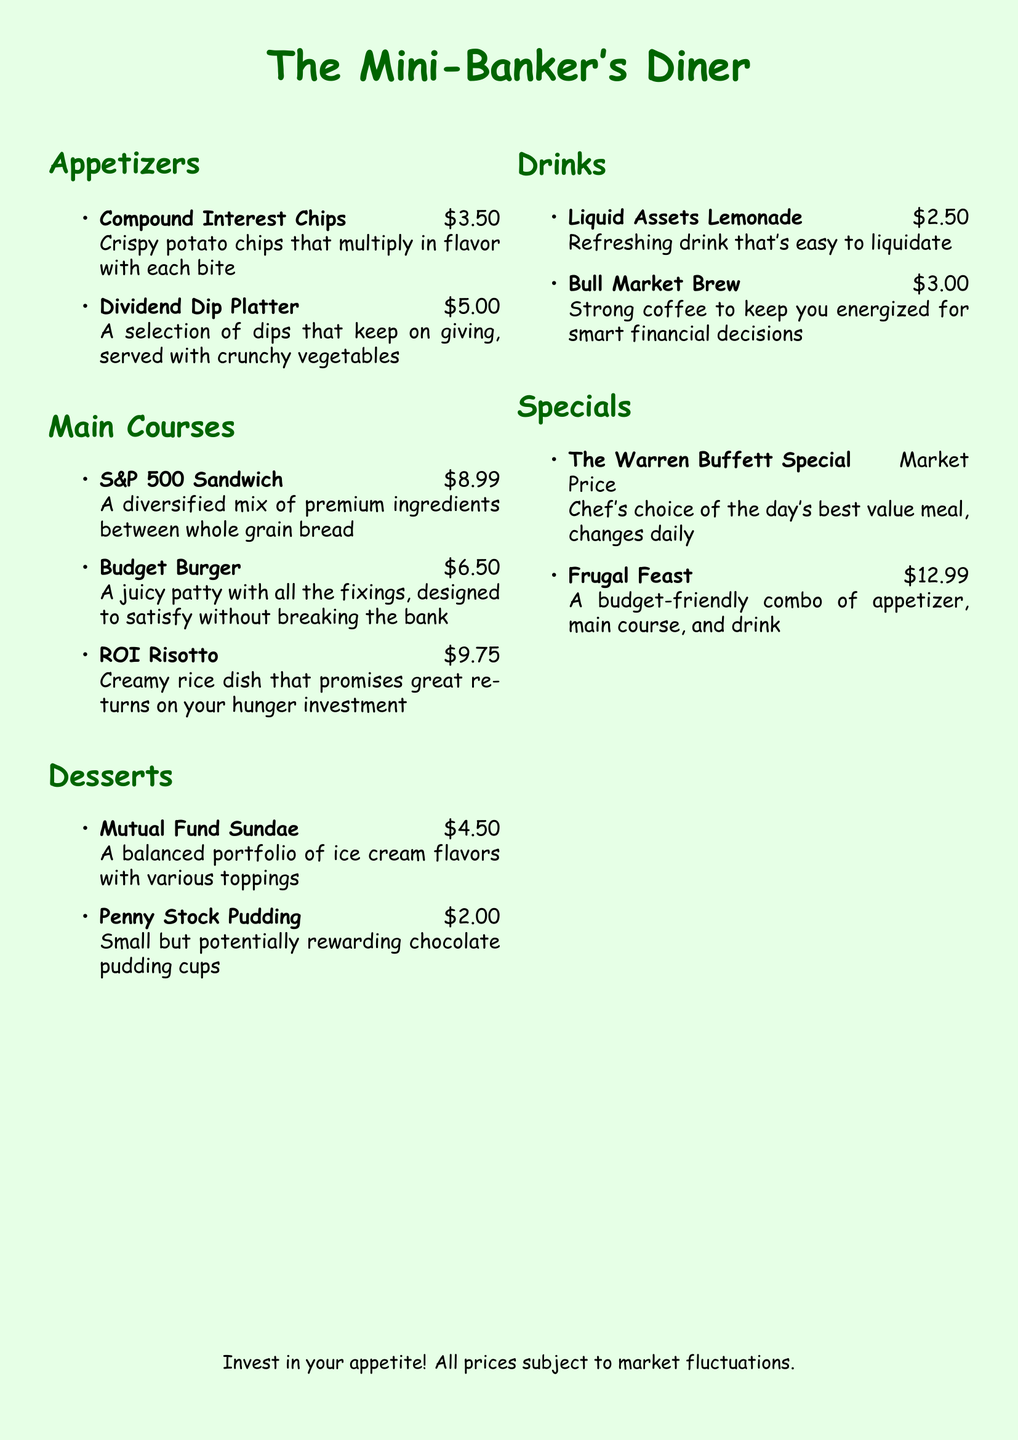what is the price of the Compound Interest Chips? The price of the Compound Interest Chips is stated in the appetizers section of the menu.
Answer: $3.50 which drink is referred to as "Liquid Assets"? The drink called "Liquid Assets" is mentioned in the drinks section of the menu.
Answer: Liquid Assets Lemonade how much does the Frugal Feast cost? The Frugal Feast price is listed under specials in the menu.
Answer: $12.99 what is the main ingredient of the S&P 500 Sandwich? The S&P 500 Sandwich is described as having a mix of premium ingredients, which indicates diversity.
Answer: premium ingredients what unique feature does the Penny Stock Pudding have? The Penny Stock Pudding is described as being small but potentially rewarding, indicating its appeal.
Answer: potentially rewarding what does the Warren Buffett Special’s price depend on? The price of the Warren Buffett Special is stated to be market price, meaning it varies daily.
Answer: market Price 